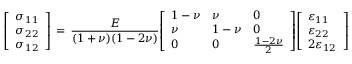Convert formula to latex. <formula><loc_0><loc_0><loc_500><loc_500>{ \left [ \begin{array} { l } { \sigma _ { 1 1 } } \\ { \sigma _ { 2 2 } } \\ { \sigma _ { 1 2 } } \end{array} \right ] } \, = \, { \frac { E } { ( 1 + \nu ) ( 1 - 2 \nu ) } } { \left [ \begin{array} { l l l } { 1 - \nu } & { \nu } & { 0 } \\ { \nu } & { 1 - \nu } & { 0 } \\ { 0 } & { 0 } & { { \frac { 1 - 2 \nu } { 2 } } } \end{array} \right ] } { \left [ \begin{array} { l } { \varepsilon _ { 1 1 } } \\ { \varepsilon _ { 2 2 } } \\ { 2 \varepsilon _ { 1 2 } } \end{array} \right ] }</formula> 